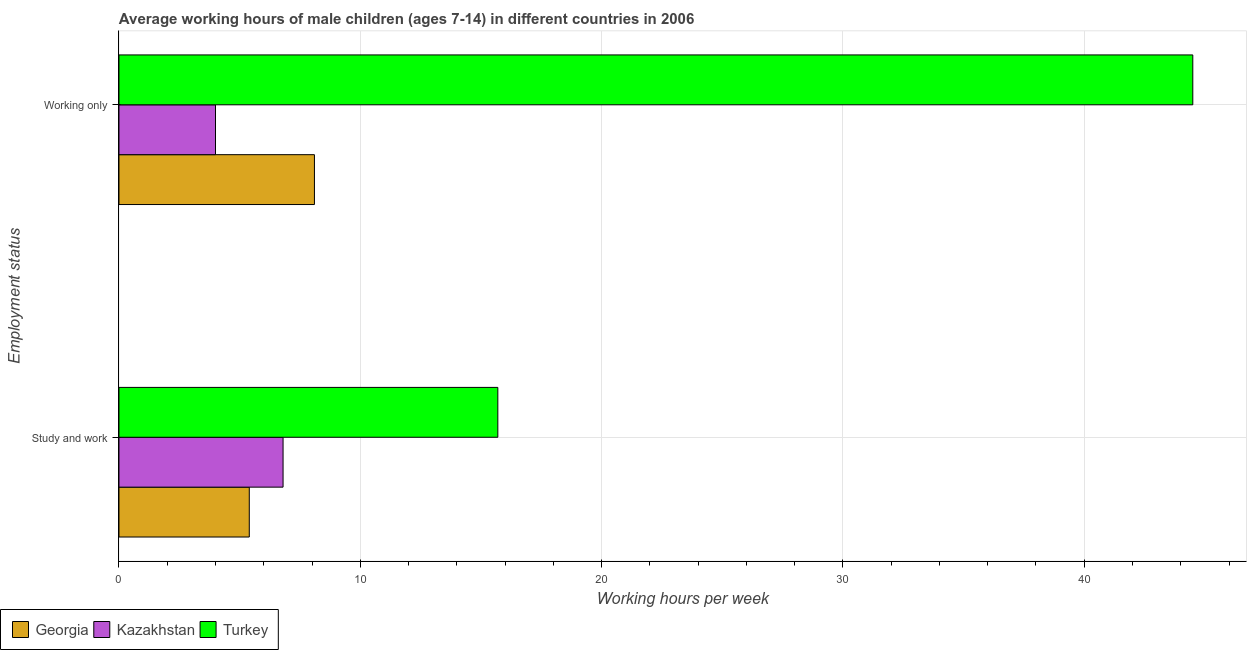How many bars are there on the 1st tick from the bottom?
Ensure brevity in your answer.  3. What is the label of the 1st group of bars from the top?
Provide a short and direct response. Working only. Across all countries, what is the maximum average working hour of children involved in study and work?
Your answer should be very brief. 15.7. Across all countries, what is the minimum average working hour of children involved in only work?
Make the answer very short. 4. In which country was the average working hour of children involved in only work minimum?
Offer a very short reply. Kazakhstan. What is the total average working hour of children involved in only work in the graph?
Provide a succinct answer. 56.6. What is the difference between the average working hour of children involved in study and work in Kazakhstan and that in Turkey?
Give a very brief answer. -8.9. What is the difference between the average working hour of children involved in only work in Turkey and the average working hour of children involved in study and work in Kazakhstan?
Keep it short and to the point. 37.7. What is the average average working hour of children involved in study and work per country?
Your answer should be compact. 9.3. What is the difference between the average working hour of children involved in only work and average working hour of children involved in study and work in Kazakhstan?
Keep it short and to the point. -2.8. In how many countries, is the average working hour of children involved in study and work greater than 28 hours?
Give a very brief answer. 0. What is the ratio of the average working hour of children involved in only work in Georgia to that in Turkey?
Offer a terse response. 0.18. Is the average working hour of children involved in only work in Kazakhstan less than that in Turkey?
Your answer should be very brief. Yes. What does the 3rd bar from the top in Study and work represents?
Your answer should be compact. Georgia. What does the 2nd bar from the bottom in Working only represents?
Offer a terse response. Kazakhstan. How many bars are there?
Give a very brief answer. 6. Does the graph contain any zero values?
Keep it short and to the point. No. How many legend labels are there?
Provide a succinct answer. 3. How are the legend labels stacked?
Provide a short and direct response. Horizontal. What is the title of the graph?
Ensure brevity in your answer.  Average working hours of male children (ages 7-14) in different countries in 2006. Does "North America" appear as one of the legend labels in the graph?
Make the answer very short. No. What is the label or title of the X-axis?
Offer a terse response. Working hours per week. What is the label or title of the Y-axis?
Provide a succinct answer. Employment status. What is the Working hours per week of Georgia in Working only?
Offer a terse response. 8.1. What is the Working hours per week of Turkey in Working only?
Your answer should be very brief. 44.5. Across all Employment status, what is the maximum Working hours per week in Kazakhstan?
Your answer should be compact. 6.8. Across all Employment status, what is the maximum Working hours per week in Turkey?
Provide a short and direct response. 44.5. Across all Employment status, what is the minimum Working hours per week in Georgia?
Make the answer very short. 5.4. Across all Employment status, what is the minimum Working hours per week in Kazakhstan?
Your answer should be very brief. 4. What is the total Working hours per week in Georgia in the graph?
Offer a very short reply. 13.5. What is the total Working hours per week of Turkey in the graph?
Offer a very short reply. 60.2. What is the difference between the Working hours per week in Kazakhstan in Study and work and that in Working only?
Give a very brief answer. 2.8. What is the difference between the Working hours per week in Turkey in Study and work and that in Working only?
Provide a succinct answer. -28.8. What is the difference between the Working hours per week in Georgia in Study and work and the Working hours per week in Kazakhstan in Working only?
Keep it short and to the point. 1.4. What is the difference between the Working hours per week in Georgia in Study and work and the Working hours per week in Turkey in Working only?
Offer a terse response. -39.1. What is the difference between the Working hours per week of Kazakhstan in Study and work and the Working hours per week of Turkey in Working only?
Provide a succinct answer. -37.7. What is the average Working hours per week in Georgia per Employment status?
Provide a succinct answer. 6.75. What is the average Working hours per week of Kazakhstan per Employment status?
Offer a terse response. 5.4. What is the average Working hours per week in Turkey per Employment status?
Keep it short and to the point. 30.1. What is the difference between the Working hours per week of Kazakhstan and Working hours per week of Turkey in Study and work?
Offer a terse response. -8.9. What is the difference between the Working hours per week of Georgia and Working hours per week of Turkey in Working only?
Offer a terse response. -36.4. What is the difference between the Working hours per week of Kazakhstan and Working hours per week of Turkey in Working only?
Provide a short and direct response. -40.5. What is the ratio of the Working hours per week in Kazakhstan in Study and work to that in Working only?
Your answer should be compact. 1.7. What is the ratio of the Working hours per week of Turkey in Study and work to that in Working only?
Your answer should be very brief. 0.35. What is the difference between the highest and the second highest Working hours per week of Kazakhstan?
Your answer should be very brief. 2.8. What is the difference between the highest and the second highest Working hours per week in Turkey?
Make the answer very short. 28.8. What is the difference between the highest and the lowest Working hours per week of Georgia?
Your answer should be very brief. 2.7. What is the difference between the highest and the lowest Working hours per week in Kazakhstan?
Make the answer very short. 2.8. What is the difference between the highest and the lowest Working hours per week of Turkey?
Your answer should be very brief. 28.8. 